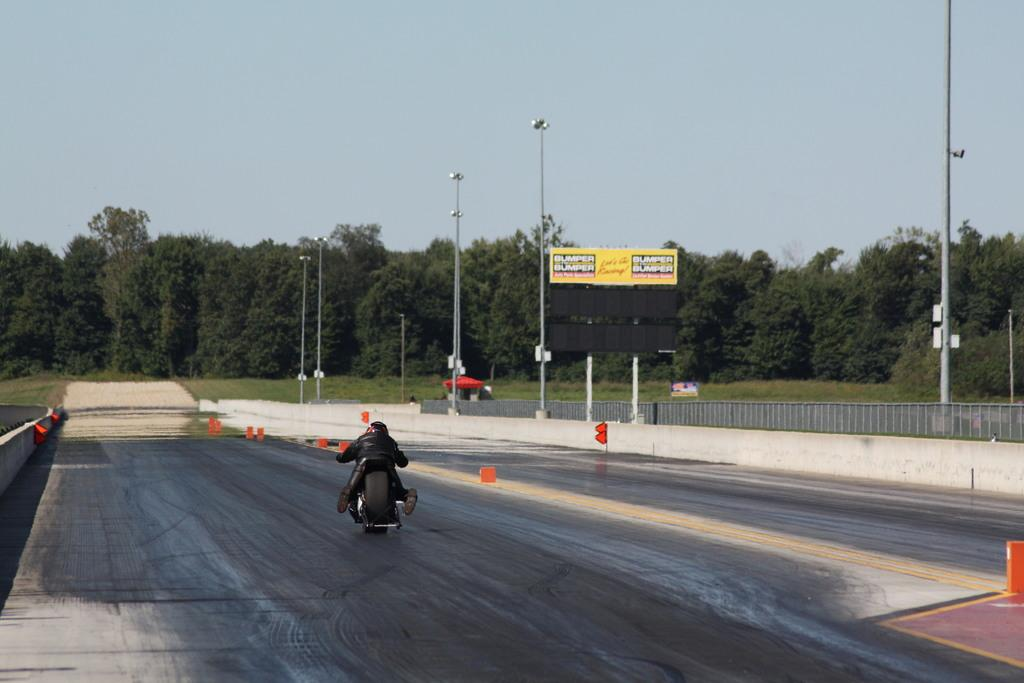What is the person in the image doing? There is a person sitting on a vehicle in the image. Where is the vehicle located? The vehicle is on a road in the image. What can be seen in the background of the image? There are trees and the sky visible in the background of the image. What other objects are present in the image? There are poles, a fence, and grass in the image. What type of scarecrow can be seen standing in the grass in the image? There is no scarecrow present in the image. How often does the person on the vehicle turn around in the image? The image does not show the person turning around, so it cannot be determined how often they do so. 